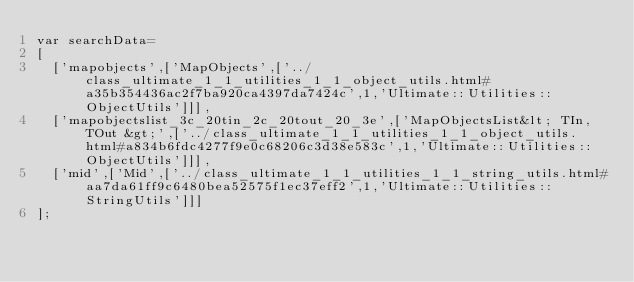Convert code to text. <code><loc_0><loc_0><loc_500><loc_500><_JavaScript_>var searchData=
[
  ['mapobjects',['MapObjects',['../class_ultimate_1_1_utilities_1_1_object_utils.html#a35b354436ac2f7ba920ca4397da7424c',1,'Ultimate::Utilities::ObjectUtils']]],
  ['mapobjectslist_3c_20tin_2c_20tout_20_3e',['MapObjectsList&lt; TIn, TOut &gt;',['../class_ultimate_1_1_utilities_1_1_object_utils.html#a834b6fdc4277f9e0c68206c3d38e583c',1,'Ultimate::Utilities::ObjectUtils']]],
  ['mid',['Mid',['../class_ultimate_1_1_utilities_1_1_string_utils.html#aa7da61ff9c6480bea52575f1ec37eff2',1,'Ultimate::Utilities::StringUtils']]]
];
</code> 